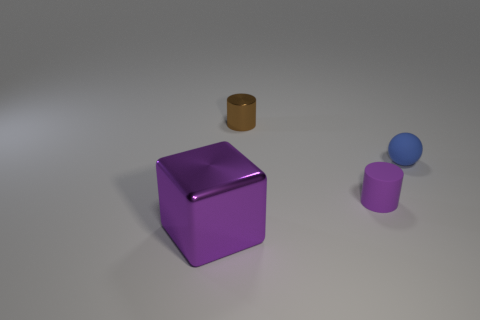There is a purple rubber thing; is it the same shape as the purple thing to the left of the small brown object? The purple object in question is not the same shape as the other purple object to the left of the small brown object, which seems to have a cylindrical shape. The first purple object is a cube with six equal square faces, while the other purple object, upon closer inspection, appears to be a cylinder with circular ends and a curved side. 